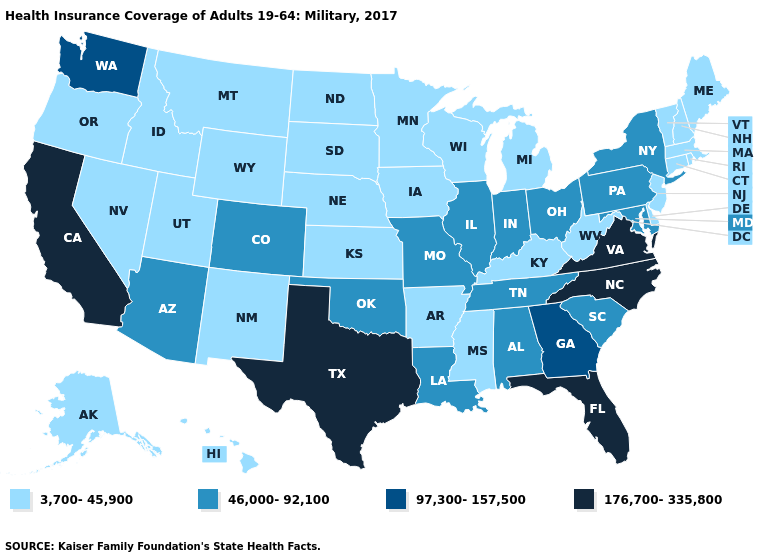Name the states that have a value in the range 176,700-335,800?
Answer briefly. California, Florida, North Carolina, Texas, Virginia. Name the states that have a value in the range 176,700-335,800?
Answer briefly. California, Florida, North Carolina, Texas, Virginia. Does North Dakota have a lower value than Florida?
Concise answer only. Yes. Among the states that border Delaware , which have the lowest value?
Keep it brief. New Jersey. What is the value of Maryland?
Give a very brief answer. 46,000-92,100. Does Utah have the highest value in the West?
Give a very brief answer. No. Does New York have the lowest value in the Northeast?
Keep it brief. No. What is the lowest value in the USA?
Give a very brief answer. 3,700-45,900. Name the states that have a value in the range 176,700-335,800?
Give a very brief answer. California, Florida, North Carolina, Texas, Virginia. What is the value of Illinois?
Keep it brief. 46,000-92,100. What is the value of Michigan?
Short answer required. 3,700-45,900. What is the lowest value in the USA?
Be succinct. 3,700-45,900. Does the first symbol in the legend represent the smallest category?
Short answer required. Yes. What is the lowest value in the USA?
Concise answer only. 3,700-45,900. Does the first symbol in the legend represent the smallest category?
Quick response, please. Yes. 